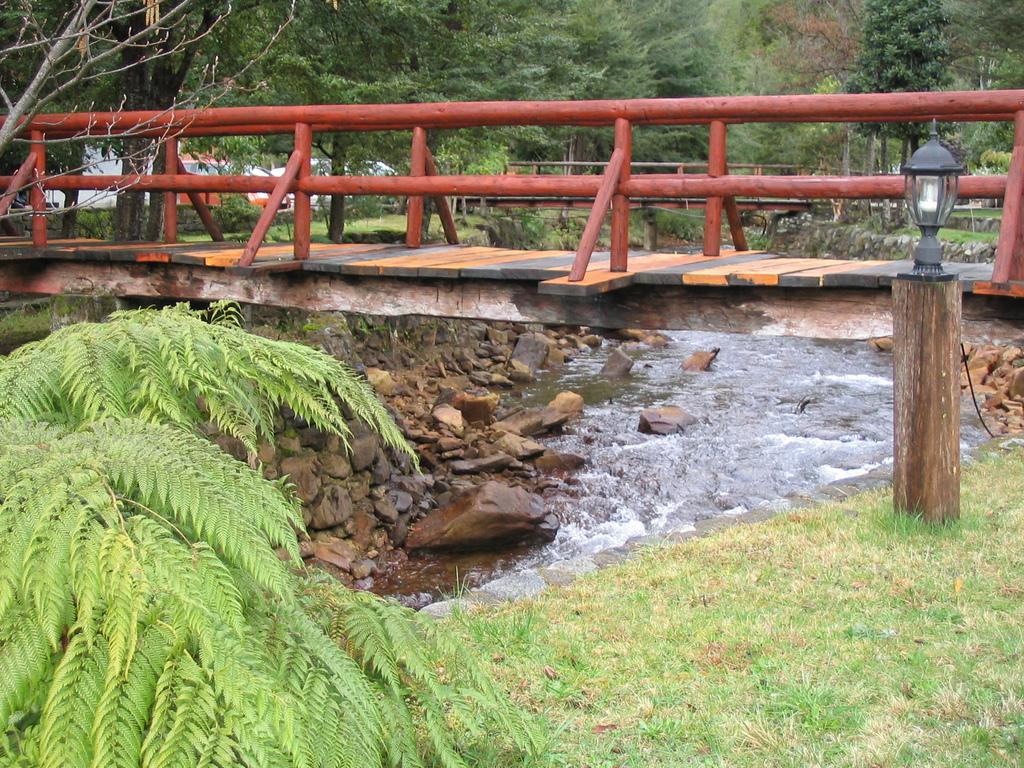What type of structure can be seen in the image? There is a bridge in the image. What type of vegetation is present in the image? There are trees and grass in the image. What body of water is visible in the image? There is water in the image. What type of terrain is depicted in the image? There are stones in the image. What is the source of illumination in the image? There is light in the image. What type of transportation is present in the image? There are vehicles in the image. What type of leather is used to make the plate in the image? There is no plate or leather present in the image. How many fingers can be seen holding the bridge in the image? There are no fingers holding the bridge in the image; it is a stationary structure. 